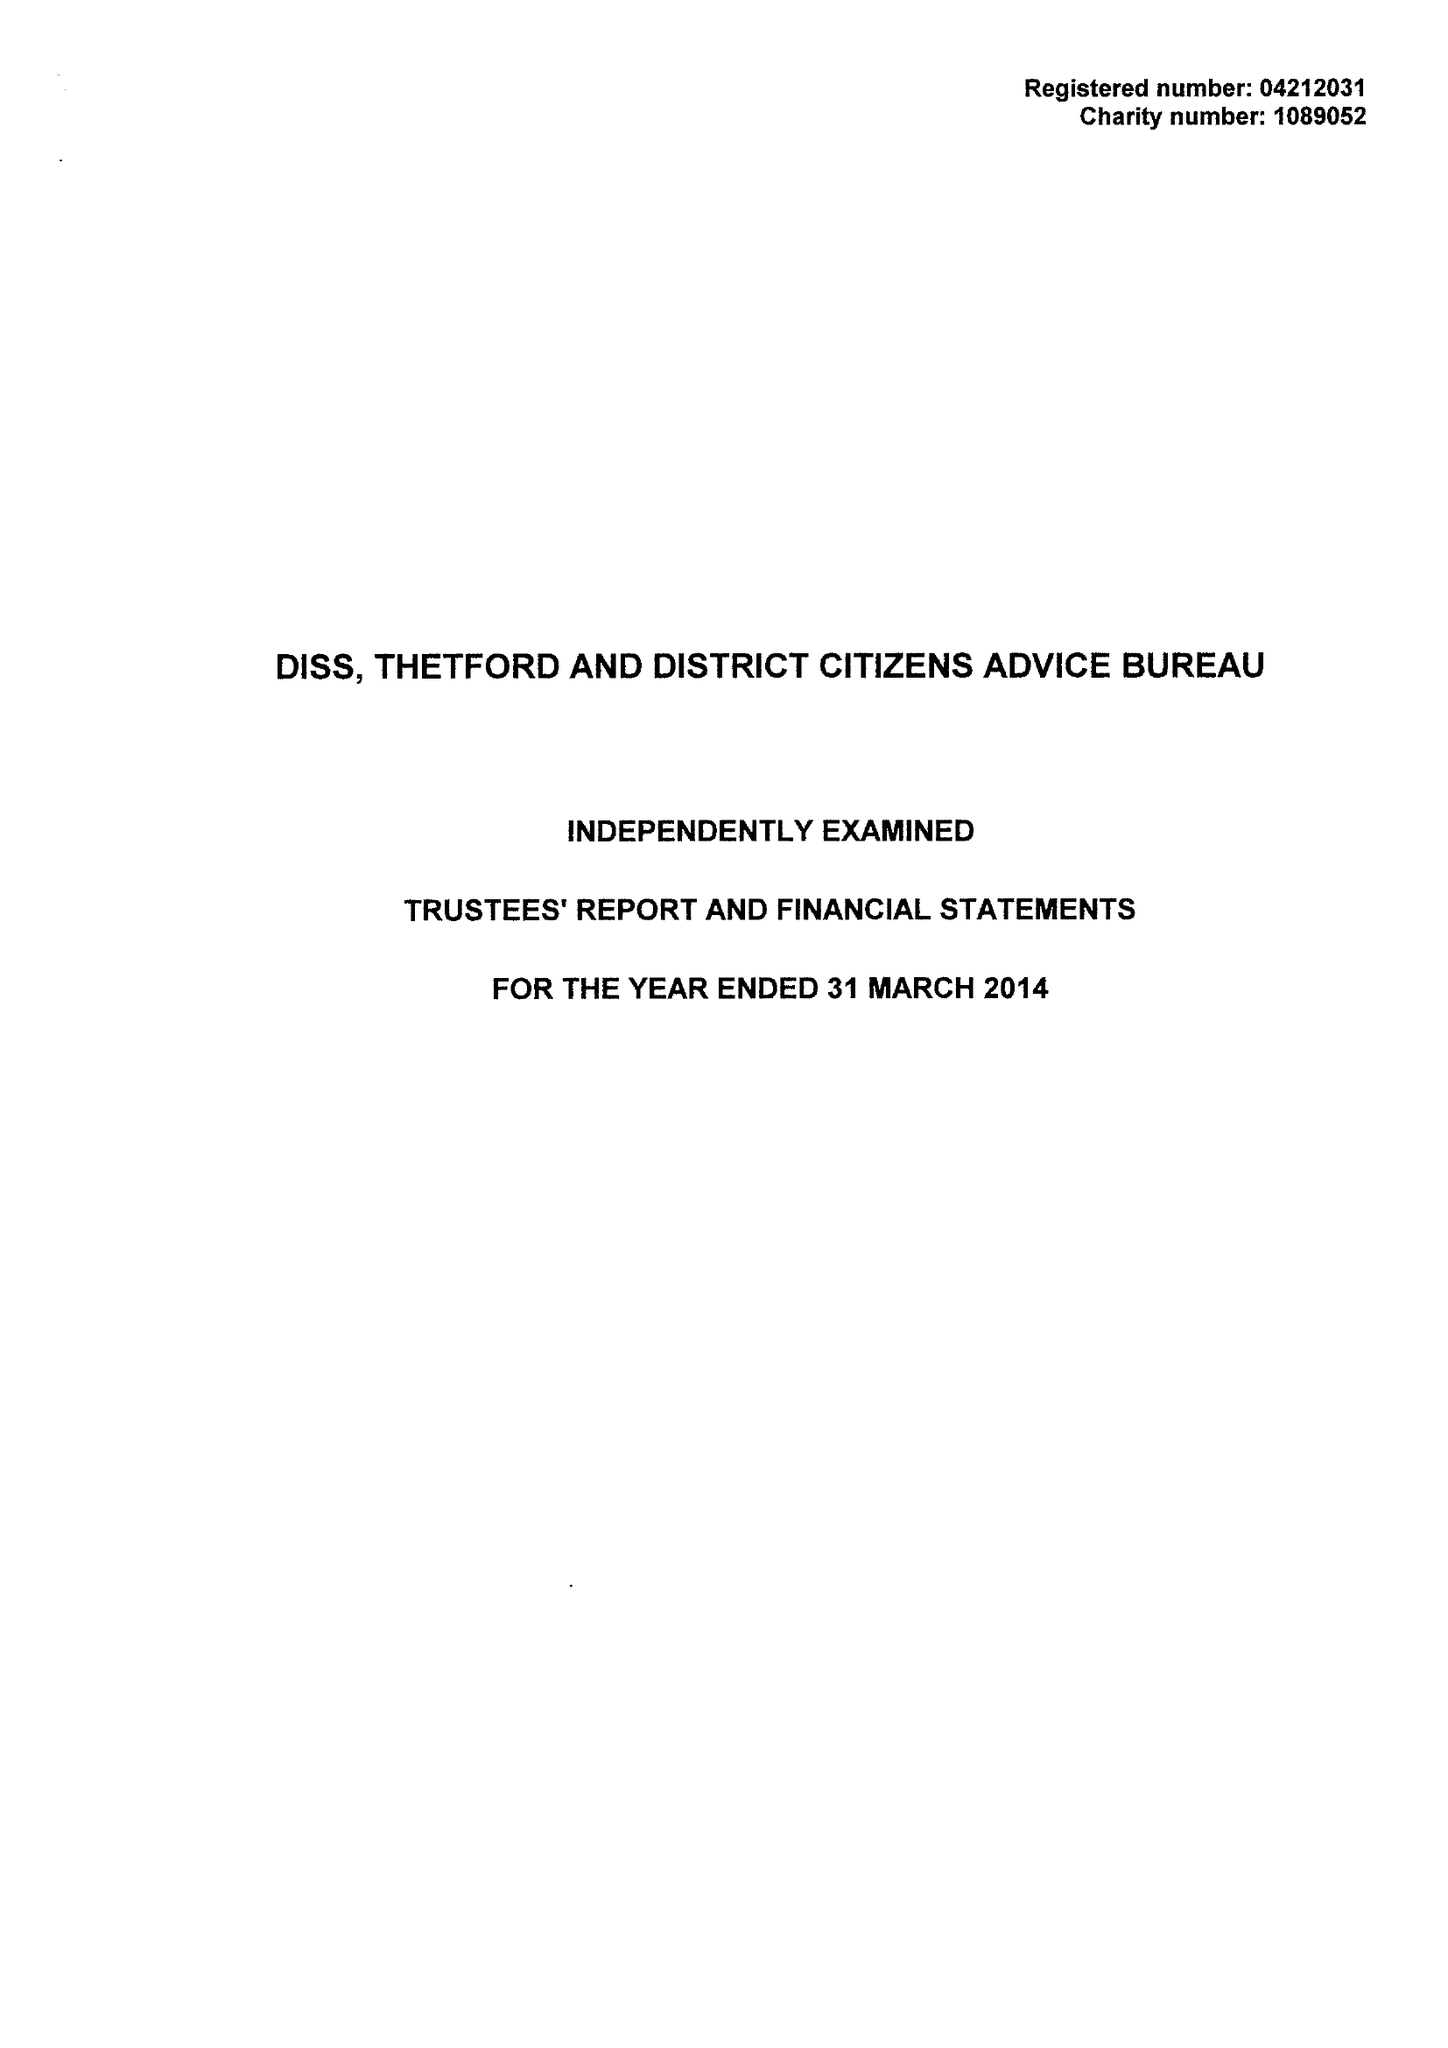What is the value for the address__postcode?
Answer the question using a single word or phrase. IP22 4EH 